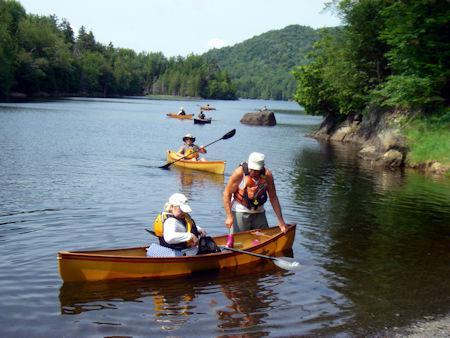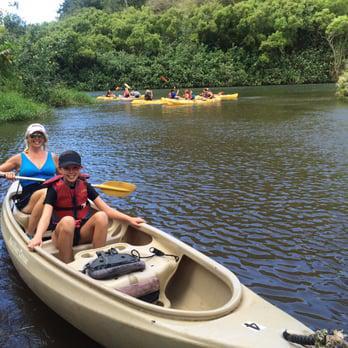The first image is the image on the left, the second image is the image on the right. Evaluate the accuracy of this statement regarding the images: "there is a canoe on the beach with a row of tree trunks to the right". Is it true? Answer yes or no. No. The first image is the image on the left, the second image is the image on the right. For the images shown, is this caption "There are at least four boats in total." true? Answer yes or no. Yes. 